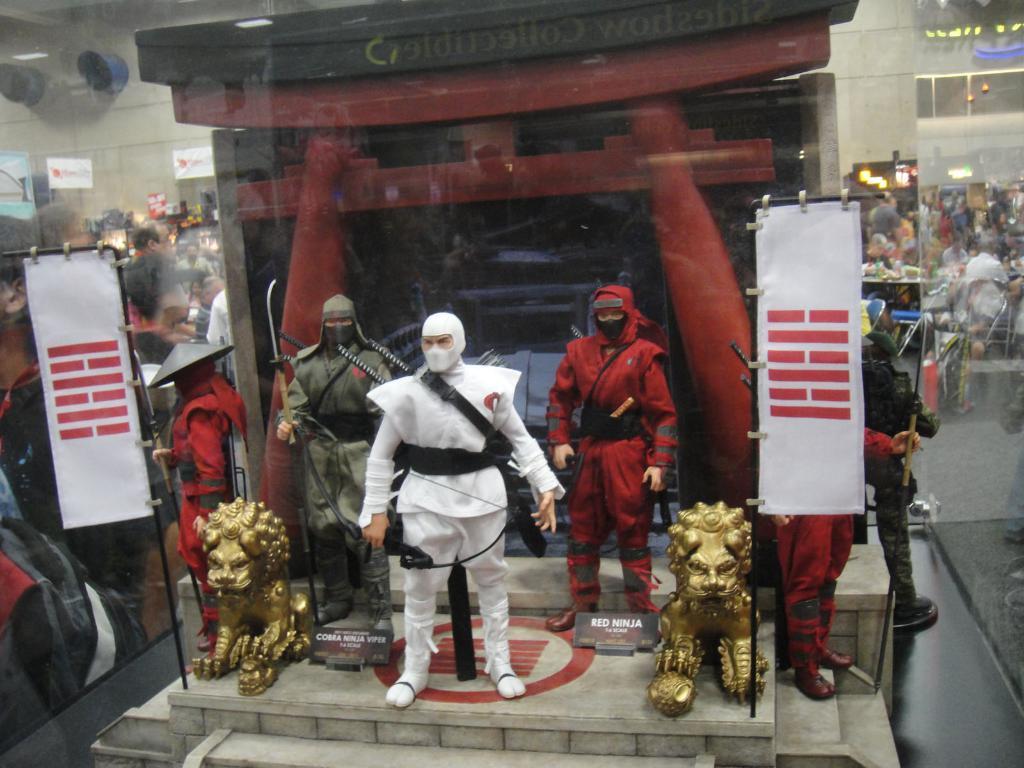Can you describe this image briefly? In this image there is a glass, it looks like there are statues in the foreground. And there is a glass in which we can see people and other objects on the left and right corner. 